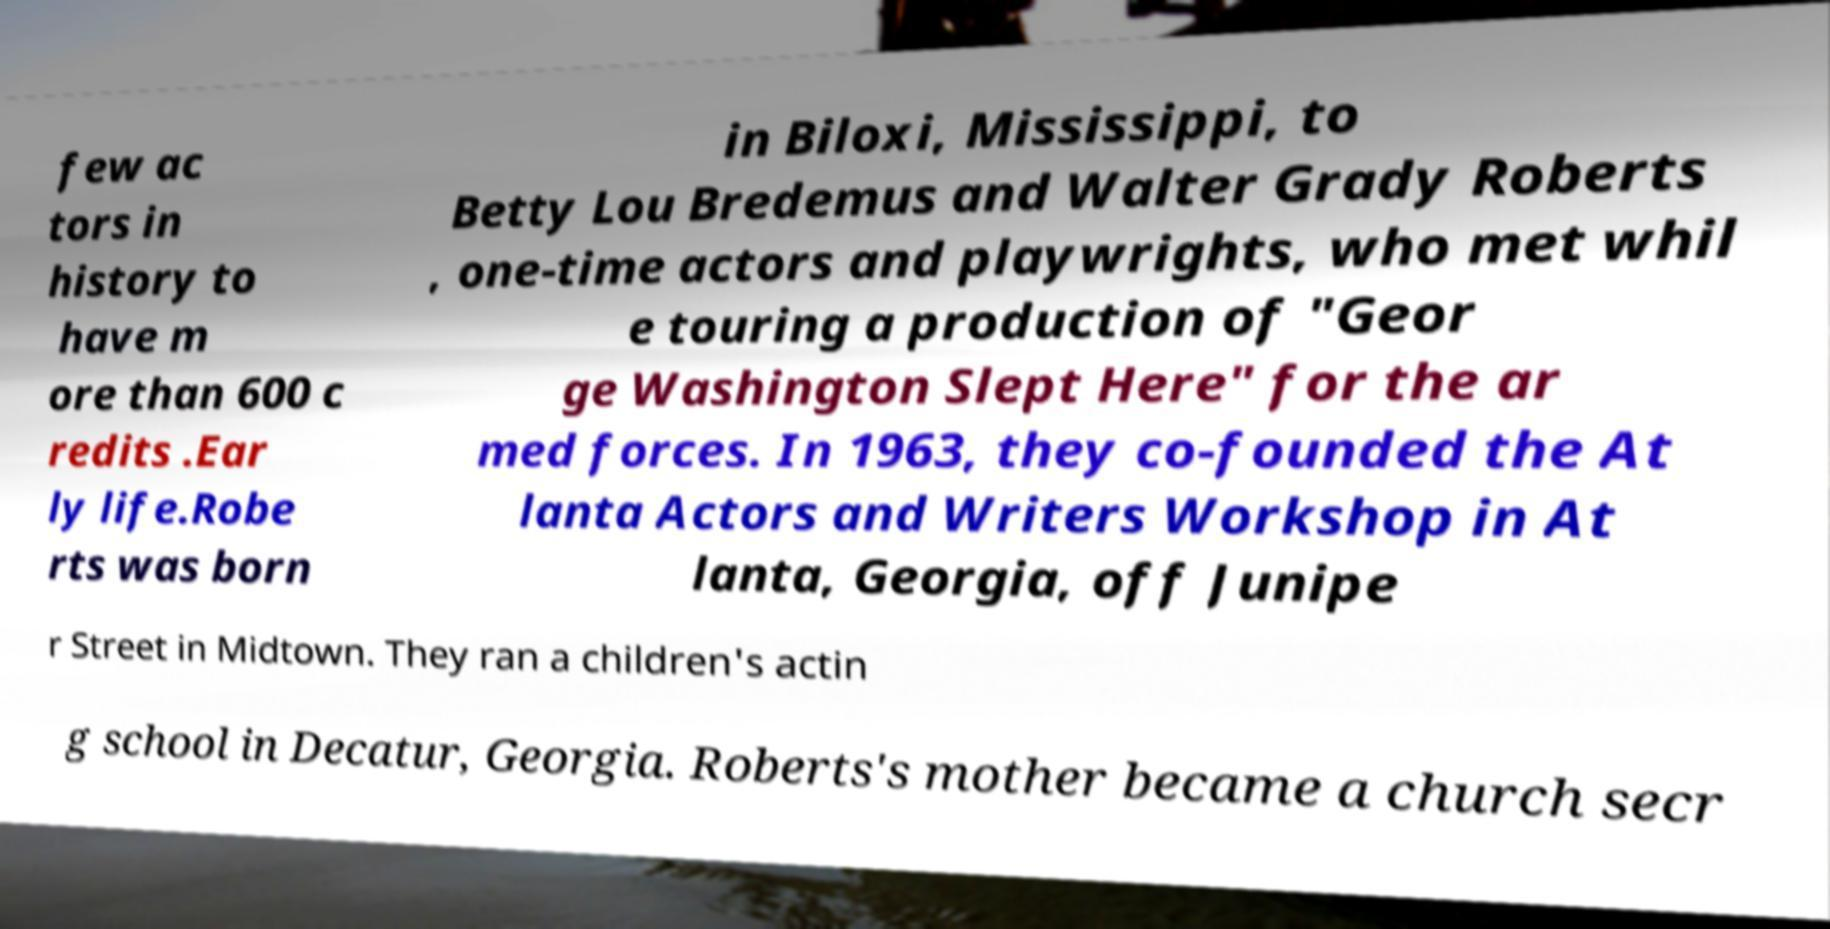I need the written content from this picture converted into text. Can you do that? few ac tors in history to have m ore than 600 c redits .Ear ly life.Robe rts was born in Biloxi, Mississippi, to Betty Lou Bredemus and Walter Grady Roberts , one-time actors and playwrights, who met whil e touring a production of "Geor ge Washington Slept Here" for the ar med forces. In 1963, they co-founded the At lanta Actors and Writers Workshop in At lanta, Georgia, off Junipe r Street in Midtown. They ran a children's actin g school in Decatur, Georgia. Roberts's mother became a church secr 